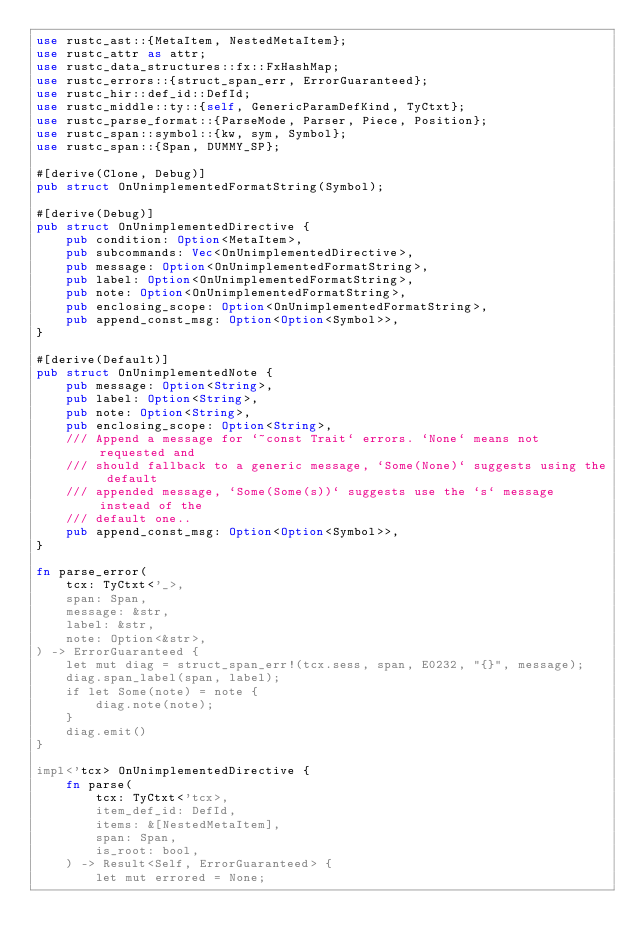Convert code to text. <code><loc_0><loc_0><loc_500><loc_500><_Rust_>use rustc_ast::{MetaItem, NestedMetaItem};
use rustc_attr as attr;
use rustc_data_structures::fx::FxHashMap;
use rustc_errors::{struct_span_err, ErrorGuaranteed};
use rustc_hir::def_id::DefId;
use rustc_middle::ty::{self, GenericParamDefKind, TyCtxt};
use rustc_parse_format::{ParseMode, Parser, Piece, Position};
use rustc_span::symbol::{kw, sym, Symbol};
use rustc_span::{Span, DUMMY_SP};

#[derive(Clone, Debug)]
pub struct OnUnimplementedFormatString(Symbol);

#[derive(Debug)]
pub struct OnUnimplementedDirective {
    pub condition: Option<MetaItem>,
    pub subcommands: Vec<OnUnimplementedDirective>,
    pub message: Option<OnUnimplementedFormatString>,
    pub label: Option<OnUnimplementedFormatString>,
    pub note: Option<OnUnimplementedFormatString>,
    pub enclosing_scope: Option<OnUnimplementedFormatString>,
    pub append_const_msg: Option<Option<Symbol>>,
}

#[derive(Default)]
pub struct OnUnimplementedNote {
    pub message: Option<String>,
    pub label: Option<String>,
    pub note: Option<String>,
    pub enclosing_scope: Option<String>,
    /// Append a message for `~const Trait` errors. `None` means not requested and
    /// should fallback to a generic message, `Some(None)` suggests using the default
    /// appended message, `Some(Some(s))` suggests use the `s` message instead of the
    /// default one..
    pub append_const_msg: Option<Option<Symbol>>,
}

fn parse_error(
    tcx: TyCtxt<'_>,
    span: Span,
    message: &str,
    label: &str,
    note: Option<&str>,
) -> ErrorGuaranteed {
    let mut diag = struct_span_err!(tcx.sess, span, E0232, "{}", message);
    diag.span_label(span, label);
    if let Some(note) = note {
        diag.note(note);
    }
    diag.emit()
}

impl<'tcx> OnUnimplementedDirective {
    fn parse(
        tcx: TyCtxt<'tcx>,
        item_def_id: DefId,
        items: &[NestedMetaItem],
        span: Span,
        is_root: bool,
    ) -> Result<Self, ErrorGuaranteed> {
        let mut errored = None;</code> 